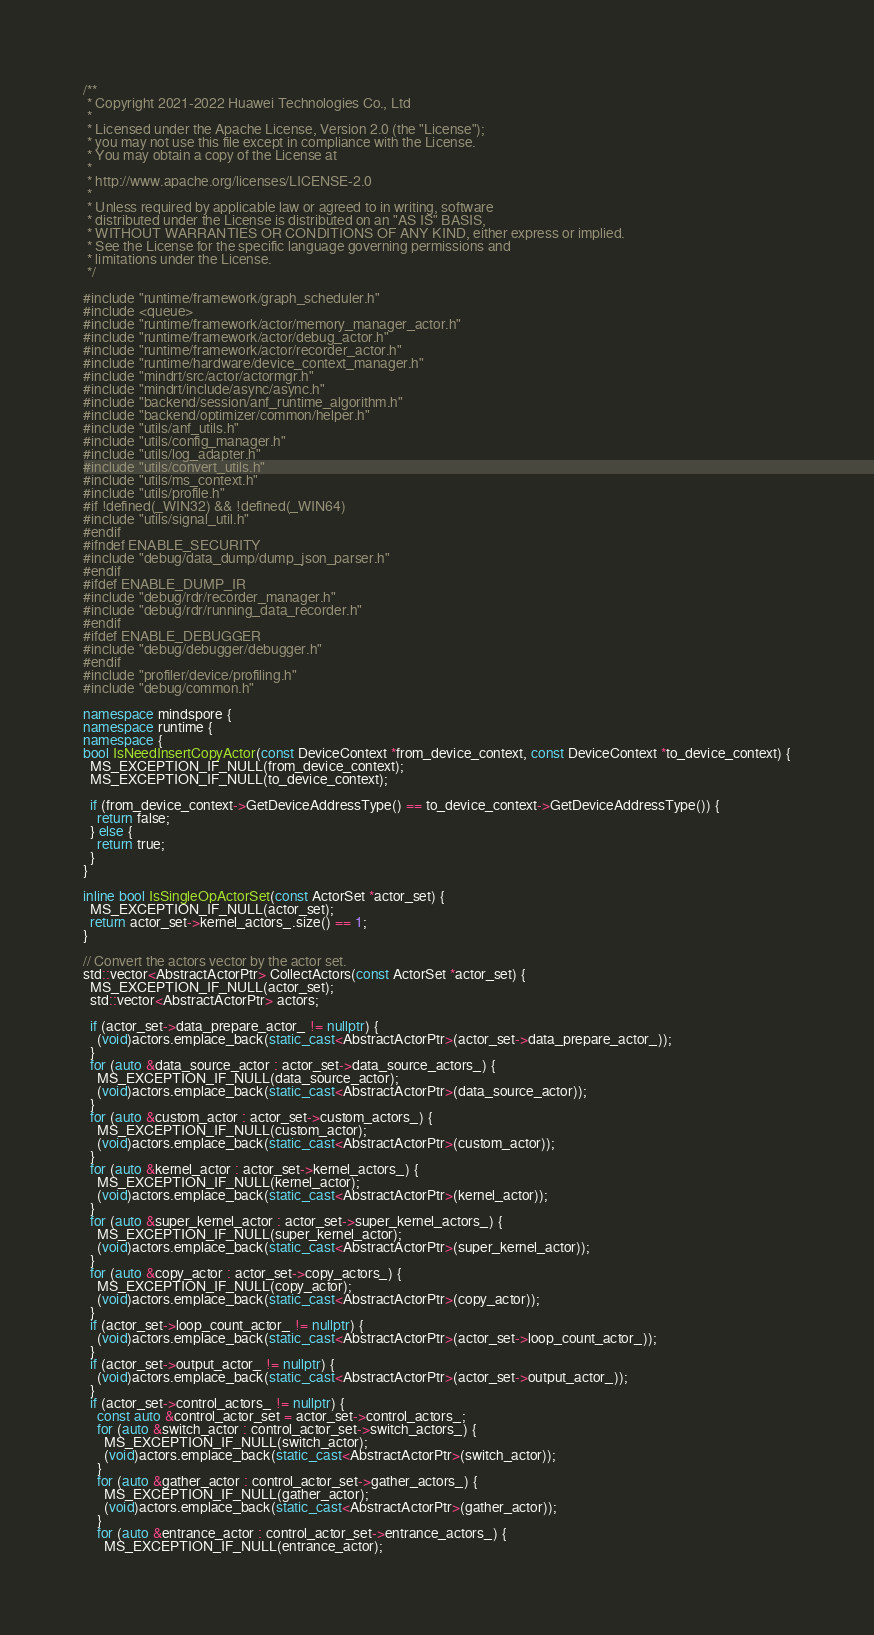<code> <loc_0><loc_0><loc_500><loc_500><_C++_>/**
 * Copyright 2021-2022 Huawei Technologies Co., Ltd
 *
 * Licensed under the Apache License, Version 2.0 (the "License");
 * you may not use this file except in compliance with the License.
 * You may obtain a copy of the License at
 *
 * http://www.apache.org/licenses/LICENSE-2.0
 *
 * Unless required by applicable law or agreed to in writing, software
 * distributed under the License is distributed on an "AS IS" BASIS,
 * WITHOUT WARRANTIES OR CONDITIONS OF ANY KIND, either express or implied.
 * See the License for the specific language governing permissions and
 * limitations under the License.
 */

#include "runtime/framework/graph_scheduler.h"
#include <queue>
#include "runtime/framework/actor/memory_manager_actor.h"
#include "runtime/framework/actor/debug_actor.h"
#include "runtime/framework/actor/recorder_actor.h"
#include "runtime/hardware/device_context_manager.h"
#include "mindrt/src/actor/actormgr.h"
#include "mindrt/include/async/async.h"
#include "backend/session/anf_runtime_algorithm.h"
#include "backend/optimizer/common/helper.h"
#include "utils/anf_utils.h"
#include "utils/config_manager.h"
#include "utils/log_adapter.h"
#include "utils/convert_utils.h"
#include "utils/ms_context.h"
#include "utils/profile.h"
#if !defined(_WIN32) && !defined(_WIN64)
#include "utils/signal_util.h"
#endif
#ifndef ENABLE_SECURITY
#include "debug/data_dump/dump_json_parser.h"
#endif
#ifdef ENABLE_DUMP_IR
#include "debug/rdr/recorder_manager.h"
#include "debug/rdr/running_data_recorder.h"
#endif
#ifdef ENABLE_DEBUGGER
#include "debug/debugger/debugger.h"
#endif
#include "profiler/device/profiling.h"
#include "debug/common.h"

namespace mindspore {
namespace runtime {
namespace {
bool IsNeedInsertCopyActor(const DeviceContext *from_device_context, const DeviceContext *to_device_context) {
  MS_EXCEPTION_IF_NULL(from_device_context);
  MS_EXCEPTION_IF_NULL(to_device_context);

  if (from_device_context->GetDeviceAddressType() == to_device_context->GetDeviceAddressType()) {
    return false;
  } else {
    return true;
  }
}

inline bool IsSingleOpActorSet(const ActorSet *actor_set) {
  MS_EXCEPTION_IF_NULL(actor_set);
  return actor_set->kernel_actors_.size() == 1;
}

// Convert the actors vector by the actor set.
std::vector<AbstractActorPtr> CollectActors(const ActorSet *actor_set) {
  MS_EXCEPTION_IF_NULL(actor_set);
  std::vector<AbstractActorPtr> actors;

  if (actor_set->data_prepare_actor_ != nullptr) {
    (void)actors.emplace_back(static_cast<AbstractActorPtr>(actor_set->data_prepare_actor_));
  }
  for (auto &data_source_actor : actor_set->data_source_actors_) {
    MS_EXCEPTION_IF_NULL(data_source_actor);
    (void)actors.emplace_back(static_cast<AbstractActorPtr>(data_source_actor));
  }
  for (auto &custom_actor : actor_set->custom_actors_) {
    MS_EXCEPTION_IF_NULL(custom_actor);
    (void)actors.emplace_back(static_cast<AbstractActorPtr>(custom_actor));
  }
  for (auto &kernel_actor : actor_set->kernel_actors_) {
    MS_EXCEPTION_IF_NULL(kernel_actor);
    (void)actors.emplace_back(static_cast<AbstractActorPtr>(kernel_actor));
  }
  for (auto &super_kernel_actor : actor_set->super_kernel_actors_) {
    MS_EXCEPTION_IF_NULL(super_kernel_actor);
    (void)actors.emplace_back(static_cast<AbstractActorPtr>(super_kernel_actor));
  }
  for (auto &copy_actor : actor_set->copy_actors_) {
    MS_EXCEPTION_IF_NULL(copy_actor);
    (void)actors.emplace_back(static_cast<AbstractActorPtr>(copy_actor));
  }
  if (actor_set->loop_count_actor_ != nullptr) {
    (void)actors.emplace_back(static_cast<AbstractActorPtr>(actor_set->loop_count_actor_));
  }
  if (actor_set->output_actor_ != nullptr) {
    (void)actors.emplace_back(static_cast<AbstractActorPtr>(actor_set->output_actor_));
  }
  if (actor_set->control_actors_ != nullptr) {
    const auto &control_actor_set = actor_set->control_actors_;
    for (auto &switch_actor : control_actor_set->switch_actors_) {
      MS_EXCEPTION_IF_NULL(switch_actor);
      (void)actors.emplace_back(static_cast<AbstractActorPtr>(switch_actor));
    }
    for (auto &gather_actor : control_actor_set->gather_actors_) {
      MS_EXCEPTION_IF_NULL(gather_actor);
      (void)actors.emplace_back(static_cast<AbstractActorPtr>(gather_actor));
    }
    for (auto &entrance_actor : control_actor_set->entrance_actors_) {
      MS_EXCEPTION_IF_NULL(entrance_actor);</code> 